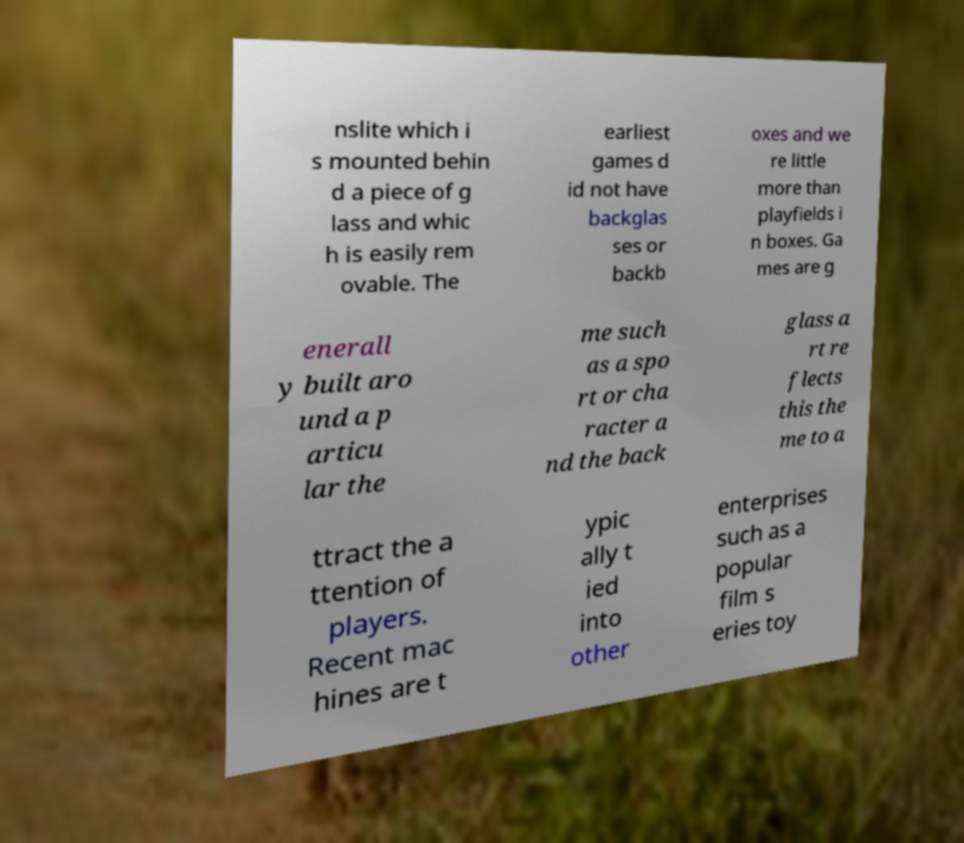For documentation purposes, I need the text within this image transcribed. Could you provide that? nslite which i s mounted behin d a piece of g lass and whic h is easily rem ovable. The earliest games d id not have backglas ses or backb oxes and we re little more than playfields i n boxes. Ga mes are g enerall y built aro und a p articu lar the me such as a spo rt or cha racter a nd the back glass a rt re flects this the me to a ttract the a ttention of players. Recent mac hines are t ypic ally t ied into other enterprises such as a popular film s eries toy 